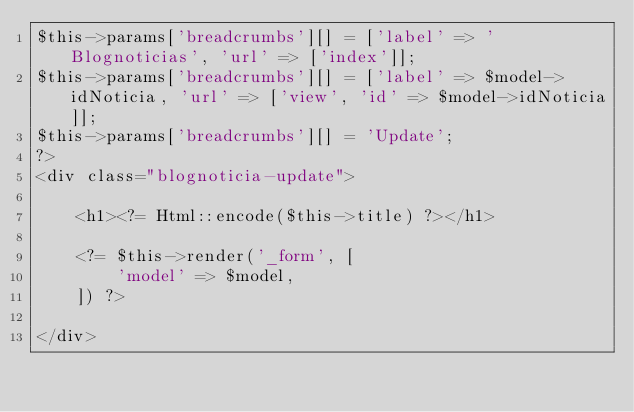Convert code to text. <code><loc_0><loc_0><loc_500><loc_500><_PHP_>$this->params['breadcrumbs'][] = ['label' => 'Blognoticias', 'url' => ['index']];
$this->params['breadcrumbs'][] = ['label' => $model->idNoticia, 'url' => ['view', 'id' => $model->idNoticia]];
$this->params['breadcrumbs'][] = 'Update';
?>
<div class="blognoticia-update">

    <h1><?= Html::encode($this->title) ?></h1>

    <?= $this->render('_form', [
        'model' => $model,
    ]) ?>

</div>
</code> 